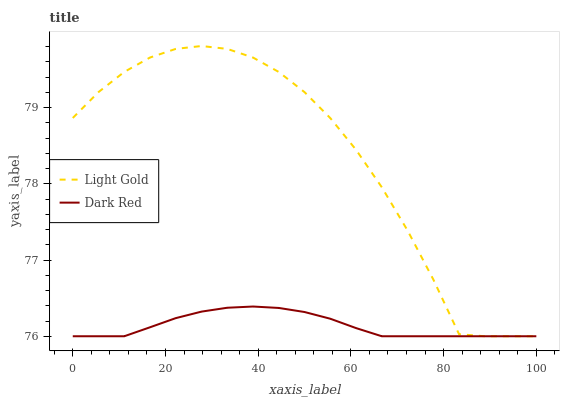Does Dark Red have the minimum area under the curve?
Answer yes or no. Yes. Does Light Gold have the maximum area under the curve?
Answer yes or no. Yes. Does Light Gold have the minimum area under the curve?
Answer yes or no. No. Is Dark Red the smoothest?
Answer yes or no. Yes. Is Light Gold the roughest?
Answer yes or no. Yes. Is Light Gold the smoothest?
Answer yes or no. No. Does Light Gold have the highest value?
Answer yes or no. Yes. 